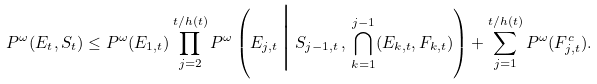<formula> <loc_0><loc_0><loc_500><loc_500>P ^ { \omega } ( E _ { t } , S _ { t } ) \leq P ^ { \omega } ( E _ { 1 , t } ) \prod _ { j = 2 } ^ { t / h ( t ) } P ^ { \omega } \left ( E _ { j , t } \, \Big | \, S _ { j - 1 , t } \, , \, \bigcap _ { k = 1 } ^ { j - 1 } ( E _ { k , t } , F _ { k , t } ) \right ) + \sum _ { j = 1 } ^ { t / h ( t ) } P ^ { \omega } ( F _ { j , t } ^ { c } ) .</formula> 